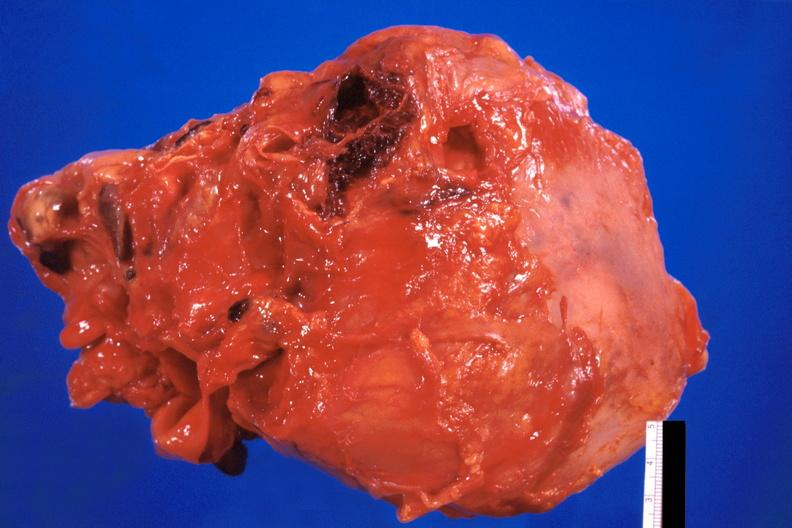does mesentery show pericarditis, secondary to mediastanitis from pseudomonas and enterobacter 14 days post op?
Answer the question using a single word or phrase. No 